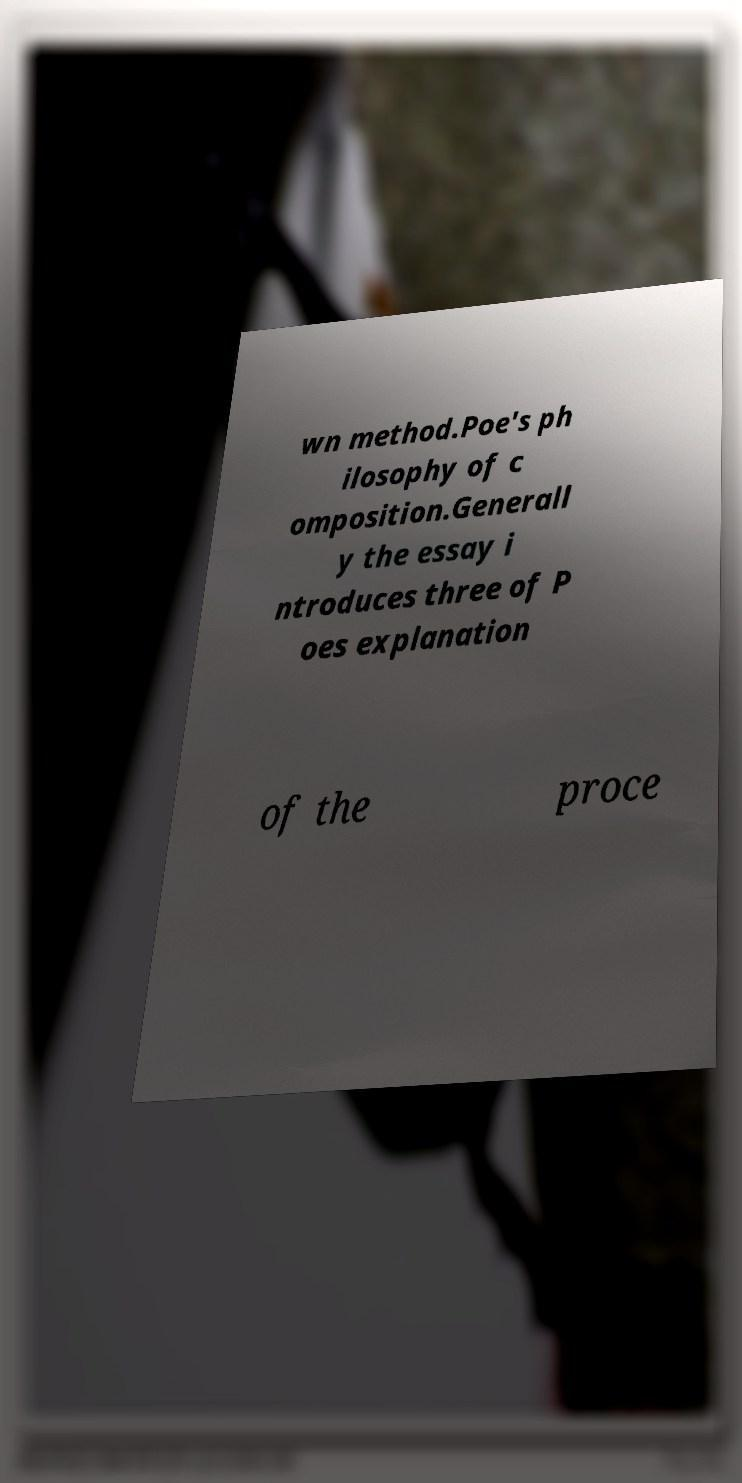Can you accurately transcribe the text from the provided image for me? wn method.Poe's ph ilosophy of c omposition.Generall y the essay i ntroduces three of P oes explanation of the proce 